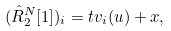Convert formula to latex. <formula><loc_0><loc_0><loc_500><loc_500>( \hat { R } _ { 2 } ^ { N } [ 1 ] ) _ { i } = t v _ { i } ( u ) + x ,</formula> 